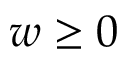Convert formula to latex. <formula><loc_0><loc_0><loc_500><loc_500>w \geq 0</formula> 